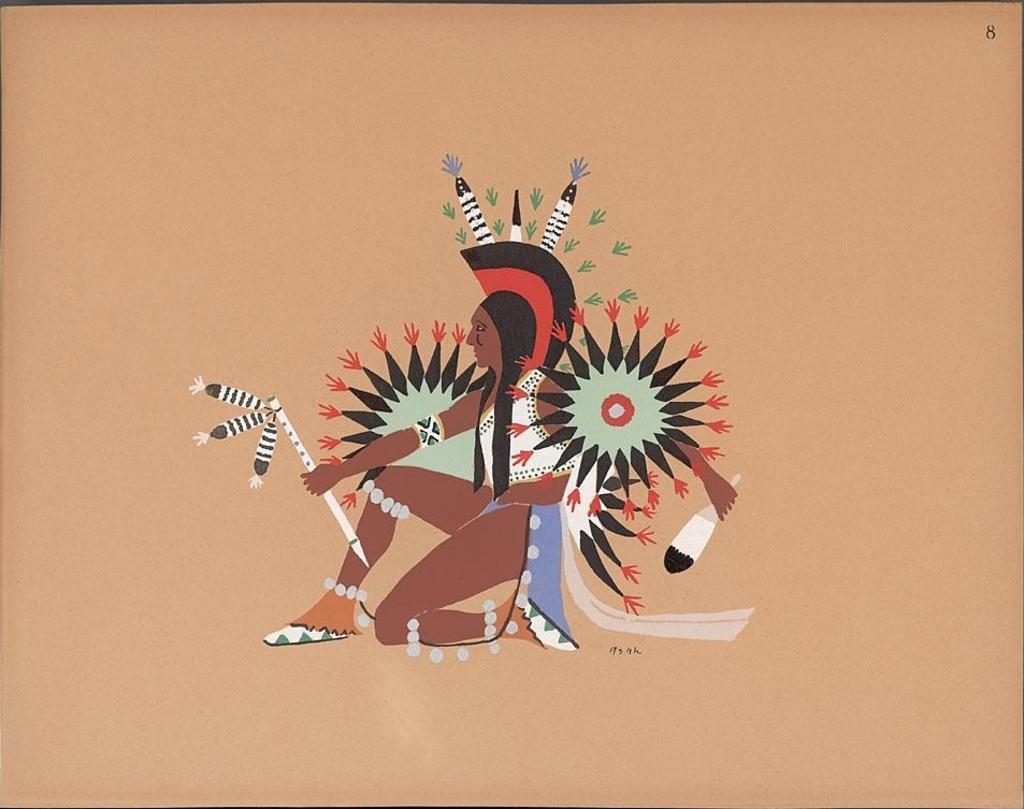What can be seen in the image? There is a person in the image. What is the person wearing? The person is wearing a different costume. What is the person holding? The person is holding objects. What is the color of the background in the image? The background of the image is cream-colored. What decision did the expert make on the island in the image? There is no expert or island present in the image; it only features a person wearing a different costume and holding objects against a cream-colored background. 